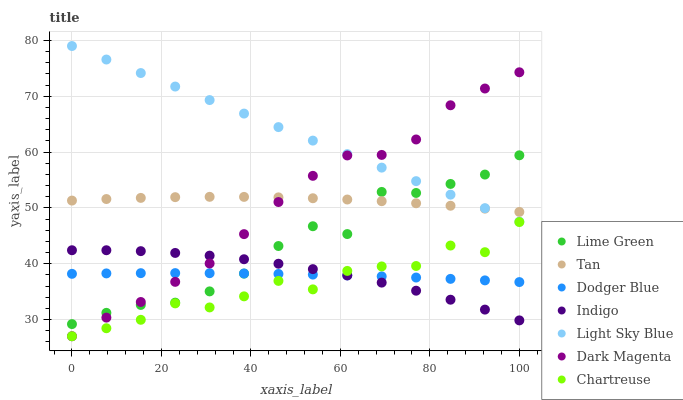Does Chartreuse have the minimum area under the curve?
Answer yes or no. Yes. Does Light Sky Blue have the maximum area under the curve?
Answer yes or no. Yes. Does Dark Magenta have the minimum area under the curve?
Answer yes or no. No. Does Dark Magenta have the maximum area under the curve?
Answer yes or no. No. Is Light Sky Blue the smoothest?
Answer yes or no. Yes. Is Chartreuse the roughest?
Answer yes or no. Yes. Is Dark Magenta the smoothest?
Answer yes or no. No. Is Dark Magenta the roughest?
Answer yes or no. No. Does Dark Magenta have the lowest value?
Answer yes or no. Yes. Does Light Sky Blue have the lowest value?
Answer yes or no. No. Does Light Sky Blue have the highest value?
Answer yes or no. Yes. Does Dark Magenta have the highest value?
Answer yes or no. No. Is Dodger Blue less than Tan?
Answer yes or no. Yes. Is Light Sky Blue greater than Dodger Blue?
Answer yes or no. Yes. Does Lime Green intersect Light Sky Blue?
Answer yes or no. Yes. Is Lime Green less than Light Sky Blue?
Answer yes or no. No. Is Lime Green greater than Light Sky Blue?
Answer yes or no. No. Does Dodger Blue intersect Tan?
Answer yes or no. No. 